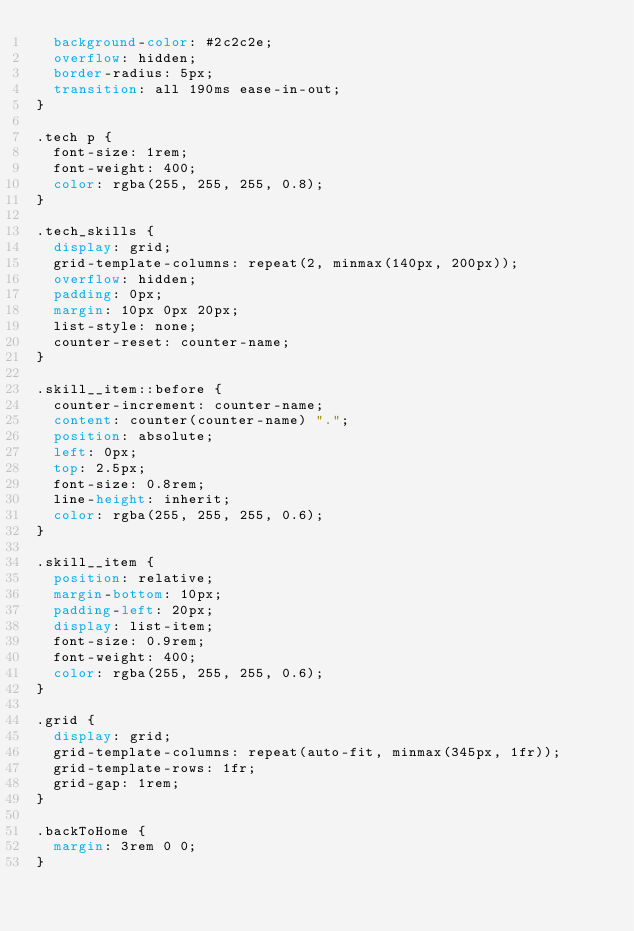Convert code to text. <code><loc_0><loc_0><loc_500><loc_500><_CSS_>  background-color: #2c2c2e;
  overflow: hidden;
  border-radius: 5px;
  transition: all 190ms ease-in-out;
}

.tech p {
  font-size: 1rem;
  font-weight: 400;
  color: rgba(255, 255, 255, 0.8);
}

.tech_skills {
  display: grid;
  grid-template-columns: repeat(2, minmax(140px, 200px));
  overflow: hidden;
  padding: 0px;
  margin: 10px 0px 20px;
  list-style: none;
  counter-reset: counter-name;
}

.skill__item::before {
  counter-increment: counter-name;
  content: counter(counter-name) ".";
  position: absolute;
  left: 0px;
  top: 2.5px;
  font-size: 0.8rem;
  line-height: inherit;
  color: rgba(255, 255, 255, 0.6);
}

.skill__item {
  position: relative;
  margin-bottom: 10px;
  padding-left: 20px;
  display: list-item;
  font-size: 0.9rem;
  font-weight: 400;
  color: rgba(255, 255, 255, 0.6);
}

.grid {
  display: grid;
  grid-template-columns: repeat(auto-fit, minmax(345px, 1fr));
  grid-template-rows: 1fr;
  grid-gap: 1rem;
}

.backToHome {
  margin: 3rem 0 0;
}
</code> 